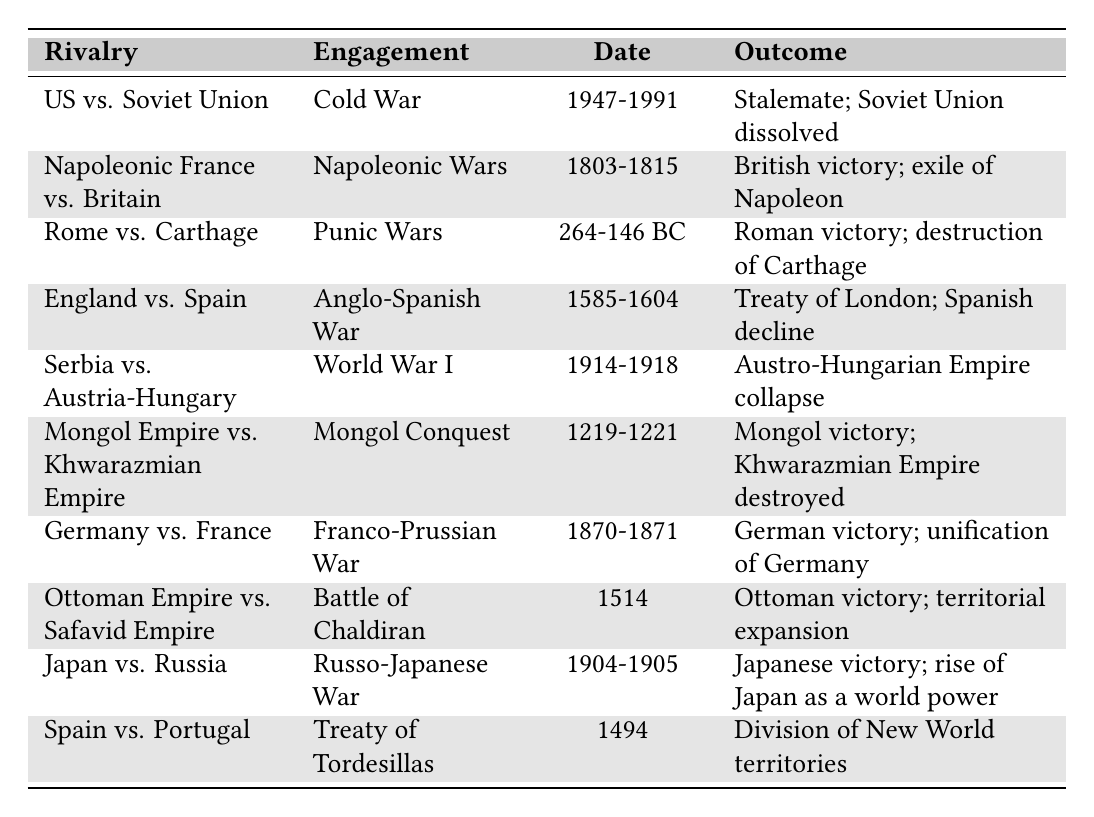What was the engagement between the United States and the Soviet Union? The table specifies that the engagement was the "Cold War."
Answer: Cold War Which rivalry ended in a stalemate? According to the table, the rivalry "United States vs. Soviet Union" ended in a stalemate.
Answer: United States vs. Soviet Union When did the Napoleonic Wars take place? The table provides the date range for the Napoleonic Wars as "1803-1815."
Answer: 1803-1815 What was the outcome of the Punic Wars? The table indicates that the outcome was "Roman victory; destruction of Carthage."
Answer: Roman victory; destruction of Carthage Did Japan win the Russo-Japanese War? The table clearly states that the outcome was "Japanese victory."
Answer: Yes Which rivalry had the date range of 1914-1918? Referring to the table, the rivalry with this date range is "Serbia vs. Austria-Hungary."
Answer: Serbia vs. Austria-Hungary How many engagements occurred before the 20th century? By counting the engagements listed in the table, there are 8 that occurred before 1900.
Answer: 8 Which engagement resulted in the unification of a country? According to the table, the "Franco-Prussian War" resulted in "unification of Germany."
Answer: Franco-Prussian War What was the outcome of the Treaty of Tordesillas? The table states the outcome was the "Division of New World territories."
Answer: Division of New World territories Compare the outcomes of the engagements between England vs. Spain and Japan vs. Russia. The table shows that England vs. Spain ended with "Treaty of London; Spanish decline" while Japan vs. Russia had "Japanese victory; rise of Japan as a world power." Hence, Japan vs. Russia had a more favorable outcome for Japan compared to the outcome for Spain.
Answer: Japan vs. Russia had a more favorable outcome 